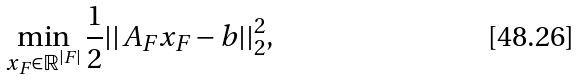Convert formula to latex. <formula><loc_0><loc_0><loc_500><loc_500>\min _ { x _ { F } \in \mathbb { R } ^ { | F | } } \frac { 1 } { 2 } | | A _ { F } x _ { F } - b | | _ { 2 } ^ { 2 } ,</formula> 